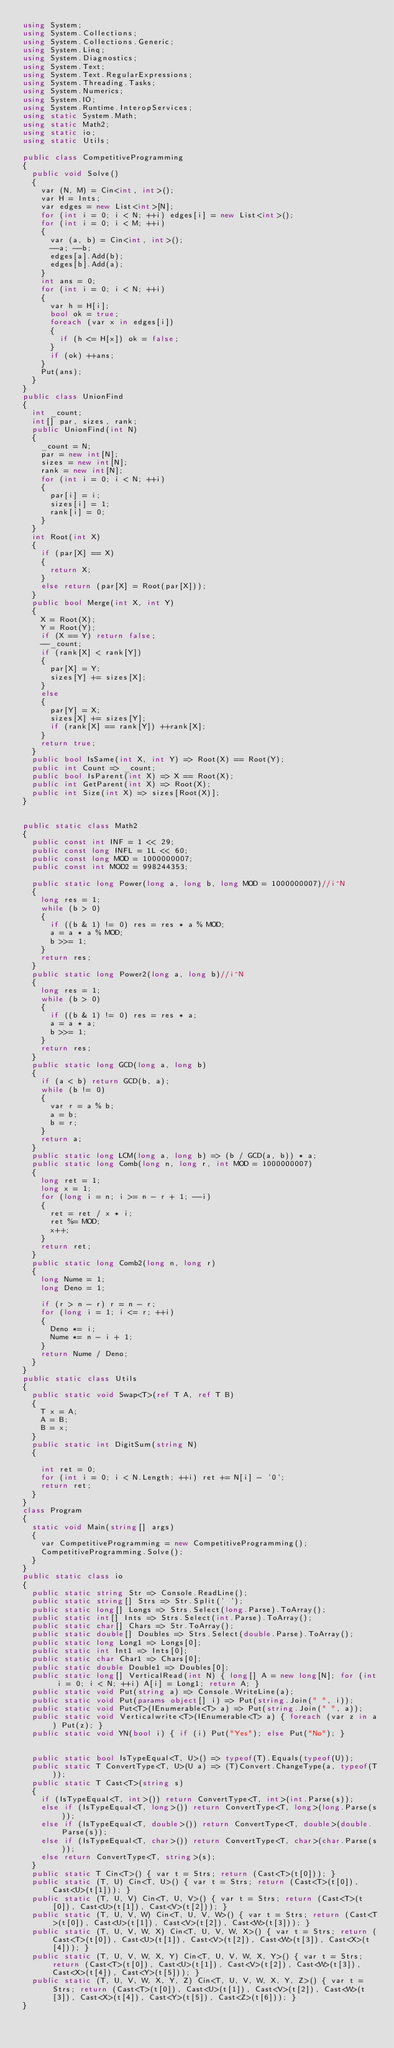Convert code to text. <code><loc_0><loc_0><loc_500><loc_500><_C#_>using System;
using System.Collections;
using System.Collections.Generic;
using System.Linq;
using System.Diagnostics;
using System.Text;
using System.Text.RegularExpressions;
using System.Threading.Tasks;
using System.Numerics;
using System.IO;
using System.Runtime.InteropServices;
using static System.Math;
using static Math2;
using static io;
using static Utils;

public class CompetitiveProgramming
{
  public void Solve()
  {
    var (N, M) = Cin<int, int>();
    var H = Ints;
    var edges = new List<int>[N];
    for (int i = 0; i < N; ++i) edges[i] = new List<int>();
    for (int i = 0; i < M; ++i)
    {
      var (a, b) = Cin<int, int>();
      --a; --b;
      edges[a].Add(b);
      edges[b].Add(a);
    }
    int ans = 0;
    for (int i = 0; i < N; ++i)
    {
      var h = H[i];
      bool ok = true;
      foreach (var x in edges[i])
      {
        if (h <= H[x]) ok = false;
      }
      if (ok) ++ans;
    }
    Put(ans);
  }
}
public class UnionFind
{
  int _count;
  int[] par, sizes, rank;
  public UnionFind(int N)
  {
    _count = N;
    par = new int[N];
    sizes = new int[N];
    rank = new int[N];
    for (int i = 0; i < N; ++i)
    {
      par[i] = i;
      sizes[i] = 1;
      rank[i] = 0;
    }
  }
  int Root(int X)
  {
    if (par[X] == X)
    {
      return X;
    }
    else return (par[X] = Root(par[X]));
  }
  public bool Merge(int X, int Y)
  {
    X = Root(X);
    Y = Root(Y);
    if (X == Y) return false;
    --_count;
    if (rank[X] < rank[Y])
    {
      par[X] = Y;
      sizes[Y] += sizes[X];
    }
    else
    {
      par[Y] = X;
      sizes[X] += sizes[Y];
      if (rank[X] == rank[Y]) ++rank[X];
    }
    return true;
  }
  public bool IsSame(int X, int Y) => Root(X) == Root(Y);
  public int Count => _count;
  public bool IsParent(int X) => X == Root(X);
  public int GetParent(int X) => Root(X);
  public int Size(int X) => sizes[Root(X)];
}


public static class Math2
{
  public const int INF = 1 << 29;
  public const long INFL = 1L << 60;
  public const long MOD = 1000000007;
  public const int MOD2 = 998244353;

  public static long Power(long a, long b, long MOD = 1000000007)//i^N
  {
    long res = 1;
    while (b > 0)
    {
      if ((b & 1) != 0) res = res * a % MOD;
      a = a * a % MOD;
      b >>= 1;
    }
    return res;
  }
  public static long Power2(long a, long b)//i^N
  {
    long res = 1;
    while (b > 0)
    {
      if ((b & 1) != 0) res = res * a;
      a = a * a;
      b >>= 1;
    }
    return res;
  }
  public static long GCD(long a, long b)
  {
    if (a < b) return GCD(b, a);
    while (b != 0)
    {
      var r = a % b;
      a = b;
      b = r;
    }
    return a;
  }
  public static long LCM(long a, long b) => (b / GCD(a, b)) * a;
  public static long Comb(long n, long r, int MOD = 1000000007)
  {
    long ret = 1;
    long x = 1;
    for (long i = n; i >= n - r + 1; --i)
    {
      ret = ret / x * i;
      ret %= MOD;
      x++;
    }
    return ret;
  }
  public static long Comb2(long n, long r)
  {
    long Nume = 1;
    long Deno = 1;

    if (r > n - r) r = n - r;
    for (long i = 1; i <= r; ++i)
    {
      Deno *= i;
      Nume *= n - i + 1;
    }
    return Nume / Deno;
  }
}
public static class Utils
{
  public static void Swap<T>(ref T A, ref T B)
  {
    T x = A;
    A = B;
    B = x;
  }
  public static int DigitSum(string N)
  {

    int ret = 0;
    for (int i = 0; i < N.Length; ++i) ret += N[i] - '0';
    return ret;
  }
}
class Program
{
  static void Main(string[] args)
  {
    var CompetitiveProgramming = new CompetitiveProgramming();
    CompetitiveProgramming.Solve();
  }
}
public static class io
{
  public static string Str => Console.ReadLine();
  public static string[] Strs => Str.Split(' ');
  public static long[] Longs => Strs.Select(long.Parse).ToArray();
  public static int[] Ints => Strs.Select(int.Parse).ToArray();
  public static char[] Chars => Str.ToArray();
  public static double[] Doubles => Strs.Select(double.Parse).ToArray();
  public static long Long1 => Longs[0];
  public static int Int1 => Ints[0];
  public static char Char1 => Chars[0];
  public static double Double1 => Doubles[0];
  public static long[] VerticalRead(int N) { long[] A = new long[N]; for (int i = 0; i < N; ++i) A[i] = Long1; return A; }
  public static void Put(string a) => Console.WriteLine(a);
  public static void Put(params object[] i) => Put(string.Join(" ", i));
  public static void Put<T>(IEnumerable<T> a) => Put(string.Join(" ", a));
  public static void Verticalwrite<T>(IEnumerable<T> a) { foreach (var z in a) Put(z); }
  public static void YN(bool i) { if (i) Put("Yes"); else Put("No"); }


  public static bool IsTypeEqual<T, U>() => typeof(T).Equals(typeof(U));
  public static T ConvertType<T, U>(U a) => (T)Convert.ChangeType(a, typeof(T));
  public static T Cast<T>(string s)
  {
    if (IsTypeEqual<T, int>()) return ConvertType<T, int>(int.Parse(s));
    else if (IsTypeEqual<T, long>()) return ConvertType<T, long>(long.Parse(s));
    else if (IsTypeEqual<T, double>()) return ConvertType<T, double>(double.Parse(s));
    else if (IsTypeEqual<T, char>()) return ConvertType<T, char>(char.Parse(s));
    else return ConvertType<T, string>(s);
  }
  public static T Cin<T>() { var t = Strs; return (Cast<T>(t[0])); }
  public static (T, U) Cin<T, U>() { var t = Strs; return (Cast<T>(t[0]), Cast<U>(t[1])); }
  public static (T, U, V) Cin<T, U, V>() { var t = Strs; return (Cast<T>(t[0]), Cast<U>(t[1]), Cast<V>(t[2])); }
  public static (T, U, V, W) Cin<T, U, V, W>() { var t = Strs; return (Cast<T>(t[0]), Cast<U>(t[1]), Cast<V>(t[2]), Cast<W>(t[3])); }
  public static (T, U, V, W, X) Cin<T, U, V, W, X>() { var t = Strs; return (Cast<T>(t[0]), Cast<U>(t[1]), Cast<V>(t[2]), Cast<W>(t[3]), Cast<X>(t[4])); }
  public static (T, U, V, W, X, Y) Cin<T, U, V, W, X, Y>() { var t = Strs; return (Cast<T>(t[0]), Cast<U>(t[1]), Cast<V>(t[2]), Cast<W>(t[3]), Cast<X>(t[4]), Cast<Y>(t[5])); }
  public static (T, U, V, W, X, Y, Z) Cin<T, U, V, W, X, Y, Z>() { var t = Strs; return (Cast<T>(t[0]), Cast<U>(t[1]), Cast<V>(t[2]), Cast<W>(t[3]), Cast<X>(t[4]), Cast<Y>(t[5]), Cast<Z>(t[6])); }
}
</code> 